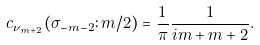<formula> <loc_0><loc_0><loc_500><loc_500>c _ { \nu _ { m + 2 } } ( \sigma _ { - m - 2 } \colon m / 2 ) = \frac { 1 } { \pi } \frac { 1 } { i m + m + 2 } .</formula> 